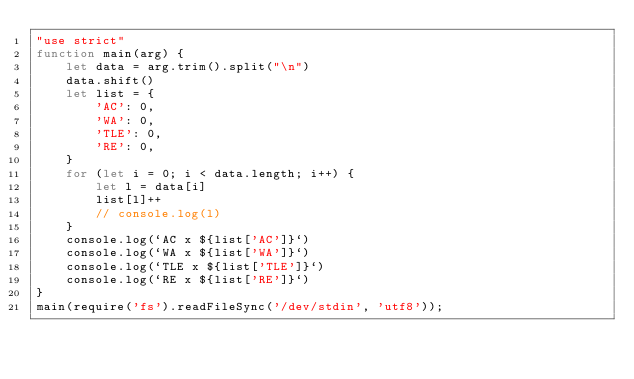<code> <loc_0><loc_0><loc_500><loc_500><_JavaScript_>"use strict"
function main(arg) {
    let data = arg.trim().split("\n")
    data.shift()
    let list = {
        'AC': 0,
        'WA': 0,
        'TLE': 0,
        'RE': 0,
    }
    for (let i = 0; i < data.length; i++) {
        let l = data[i]
        list[l]++
        // console.log(l)
    }
    console.log(`AC x ${list['AC']}`)
    console.log(`WA x ${list['WA']}`)
    console.log(`TLE x ${list['TLE']}`)
    console.log(`RE x ${list['RE']}`)
}
main(require('fs').readFileSync('/dev/stdin', 'utf8'));</code> 